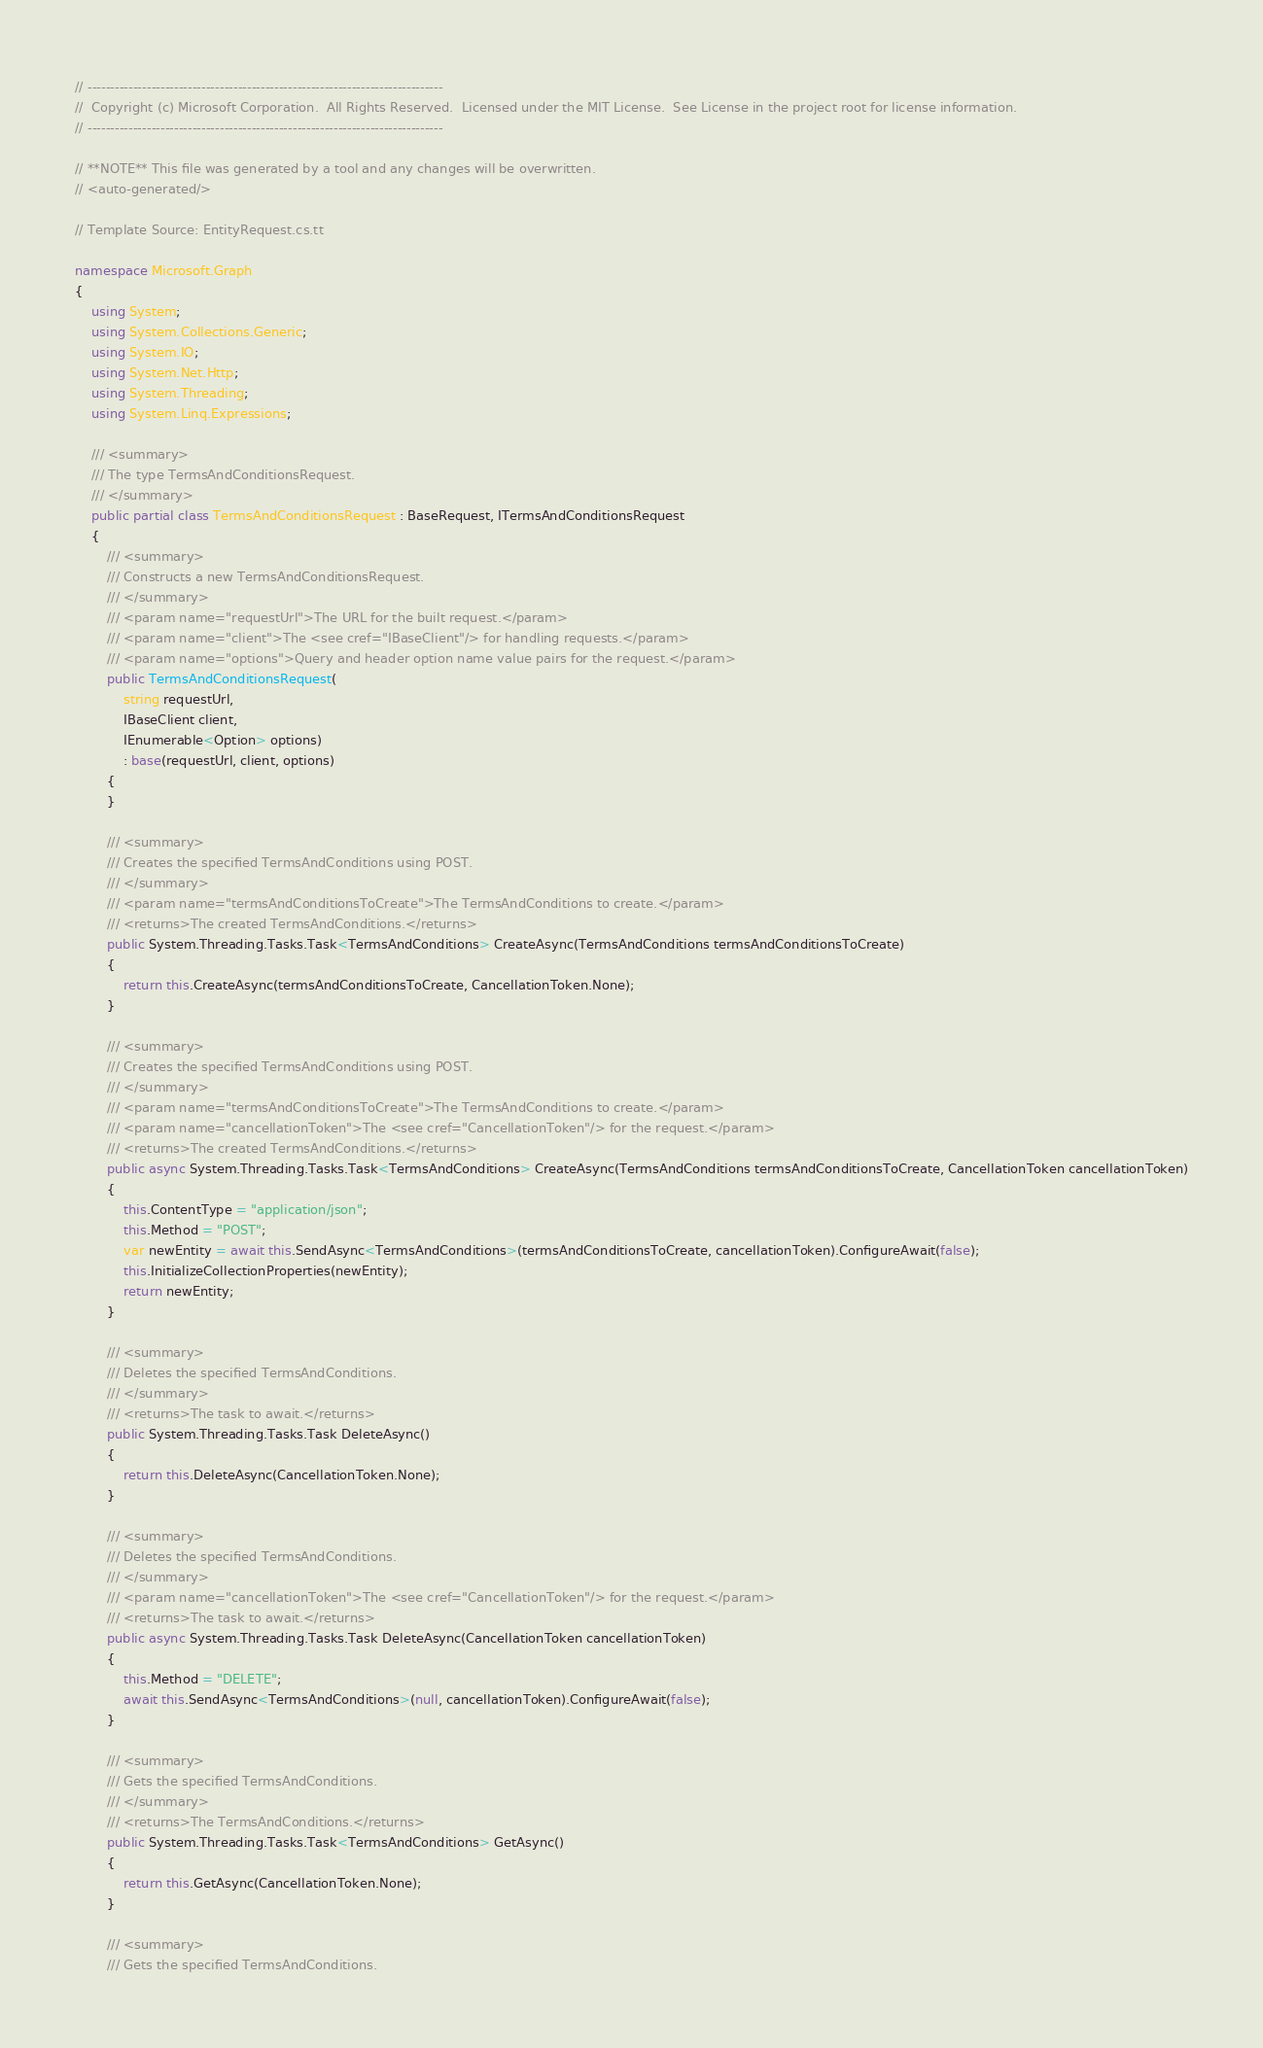<code> <loc_0><loc_0><loc_500><loc_500><_C#_>// ------------------------------------------------------------------------------
//  Copyright (c) Microsoft Corporation.  All Rights Reserved.  Licensed under the MIT License.  See License in the project root for license information.
// ------------------------------------------------------------------------------

// **NOTE** This file was generated by a tool and any changes will be overwritten.
// <auto-generated/>

// Template Source: EntityRequest.cs.tt

namespace Microsoft.Graph
{
    using System;
    using System.Collections.Generic;
    using System.IO;
    using System.Net.Http;
    using System.Threading;
    using System.Linq.Expressions;

    /// <summary>
    /// The type TermsAndConditionsRequest.
    /// </summary>
    public partial class TermsAndConditionsRequest : BaseRequest, ITermsAndConditionsRequest
    {
        /// <summary>
        /// Constructs a new TermsAndConditionsRequest.
        /// </summary>
        /// <param name="requestUrl">The URL for the built request.</param>
        /// <param name="client">The <see cref="IBaseClient"/> for handling requests.</param>
        /// <param name="options">Query and header option name value pairs for the request.</param>
        public TermsAndConditionsRequest(
            string requestUrl,
            IBaseClient client,
            IEnumerable<Option> options)
            : base(requestUrl, client, options)
        {
        }

        /// <summary>
        /// Creates the specified TermsAndConditions using POST.
        /// </summary>
        /// <param name="termsAndConditionsToCreate">The TermsAndConditions to create.</param>
        /// <returns>The created TermsAndConditions.</returns>
        public System.Threading.Tasks.Task<TermsAndConditions> CreateAsync(TermsAndConditions termsAndConditionsToCreate)
        {
            return this.CreateAsync(termsAndConditionsToCreate, CancellationToken.None);
        }

        /// <summary>
        /// Creates the specified TermsAndConditions using POST.
        /// </summary>
        /// <param name="termsAndConditionsToCreate">The TermsAndConditions to create.</param>
        /// <param name="cancellationToken">The <see cref="CancellationToken"/> for the request.</param>
        /// <returns>The created TermsAndConditions.</returns>
        public async System.Threading.Tasks.Task<TermsAndConditions> CreateAsync(TermsAndConditions termsAndConditionsToCreate, CancellationToken cancellationToken)
        {
            this.ContentType = "application/json";
            this.Method = "POST";
            var newEntity = await this.SendAsync<TermsAndConditions>(termsAndConditionsToCreate, cancellationToken).ConfigureAwait(false);
            this.InitializeCollectionProperties(newEntity);
            return newEntity;
        }

        /// <summary>
        /// Deletes the specified TermsAndConditions.
        /// </summary>
        /// <returns>The task to await.</returns>
        public System.Threading.Tasks.Task DeleteAsync()
        {
            return this.DeleteAsync(CancellationToken.None);
        }

        /// <summary>
        /// Deletes the specified TermsAndConditions.
        /// </summary>
        /// <param name="cancellationToken">The <see cref="CancellationToken"/> for the request.</param>
        /// <returns>The task to await.</returns>
        public async System.Threading.Tasks.Task DeleteAsync(CancellationToken cancellationToken)
        {
            this.Method = "DELETE";
            await this.SendAsync<TermsAndConditions>(null, cancellationToken).ConfigureAwait(false);
        }

        /// <summary>
        /// Gets the specified TermsAndConditions.
        /// </summary>
        /// <returns>The TermsAndConditions.</returns>
        public System.Threading.Tasks.Task<TermsAndConditions> GetAsync()
        {
            return this.GetAsync(CancellationToken.None);
        }

        /// <summary>
        /// Gets the specified TermsAndConditions.</code> 